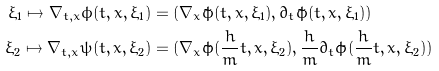<formula> <loc_0><loc_0><loc_500><loc_500>\xi _ { 1 } \mapsto \nabla _ { t , x } \phi ( t , x , \xi _ { 1 } ) & = ( \nabla _ { x } \tilde { \phi } ( t , x , \xi _ { 1 } ) , \partial _ { t } \tilde { \phi } ( t , x , \xi _ { 1 } ) ) \\ \xi _ { 2 } \mapsto \nabla _ { t , x } \psi ( t , x , \xi _ { 2 } ) & = ( \nabla _ { x } \tilde { \phi } ( \frac { h } { m } t , x , \xi _ { 2 } ) , \frac { h } { m } \partial _ { t } \tilde { \phi } ( \frac { h } { m } t , x , \xi _ { 2 } ) )</formula> 